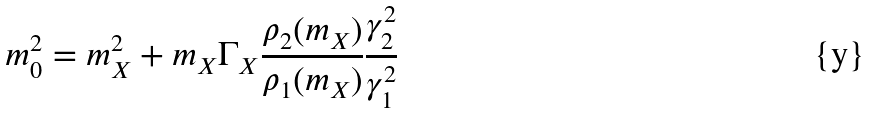Convert formula to latex. <formula><loc_0><loc_0><loc_500><loc_500>m _ { 0 } ^ { 2 } = m _ { X } ^ { 2 } + m _ { X } \Gamma _ { X } \frac { \rho _ { 2 } ( m _ { X } ) } { \rho _ { 1 } ( m _ { X } ) } \frac { \gamma _ { 2 } ^ { 2 } } { \gamma _ { 1 } ^ { 2 } }</formula> 